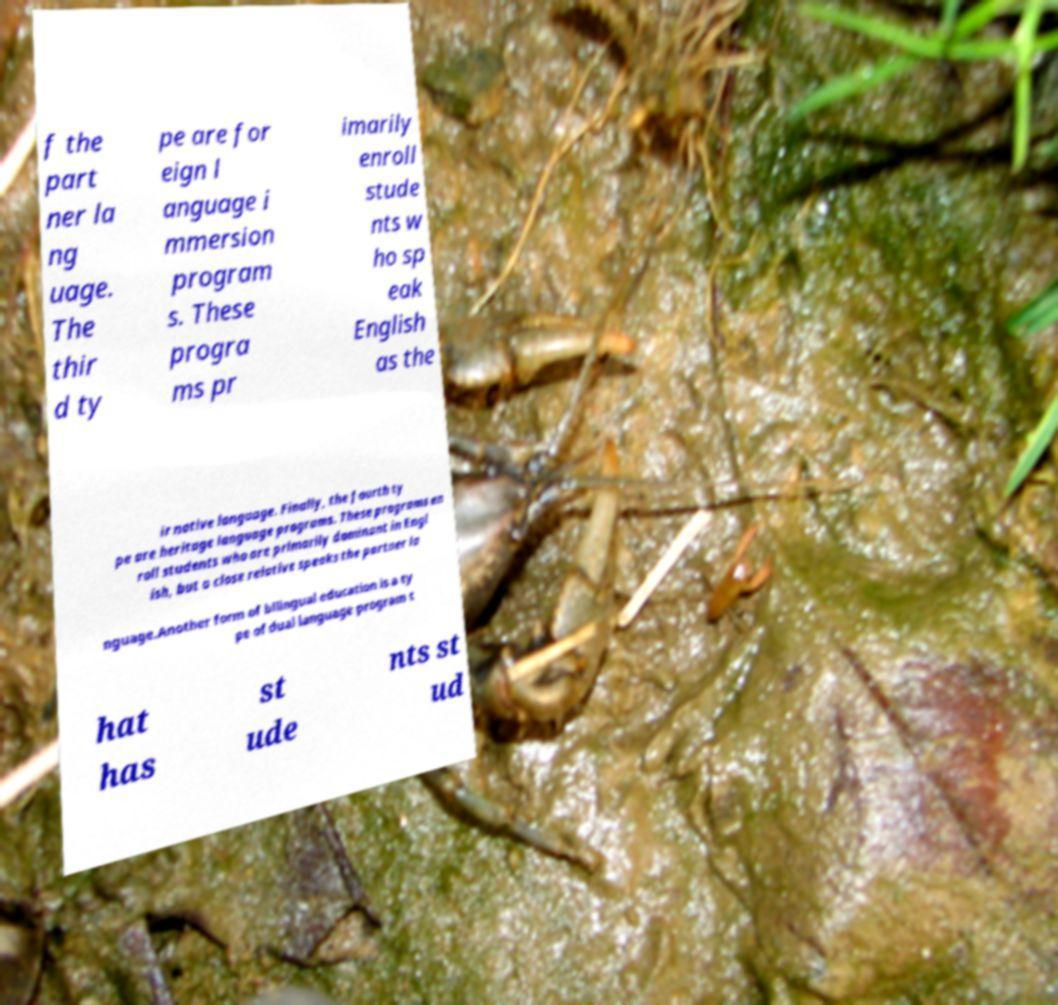I need the written content from this picture converted into text. Can you do that? f the part ner la ng uage. The thir d ty pe are for eign l anguage i mmersion program s. These progra ms pr imarily enroll stude nts w ho sp eak English as the ir native language. Finally, the fourth ty pe are heritage language programs. These programs en roll students who are primarily dominant in Engl ish, but a close relative speaks the partner la nguage.Another form of bilingual education is a ty pe of dual language program t hat has st ude nts st ud 